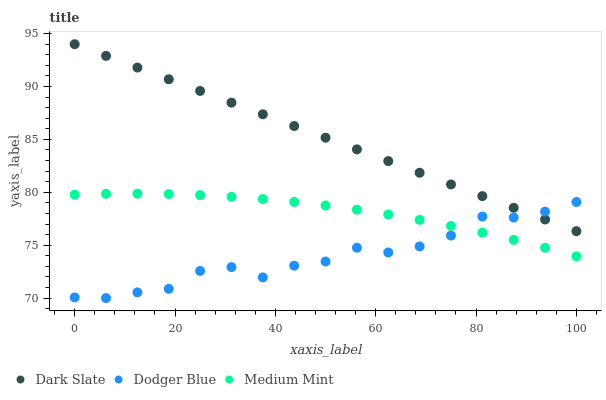Does Dodger Blue have the minimum area under the curve?
Answer yes or no. Yes. Does Dark Slate have the maximum area under the curve?
Answer yes or no. Yes. Does Dark Slate have the minimum area under the curve?
Answer yes or no. No. Does Dodger Blue have the maximum area under the curve?
Answer yes or no. No. Is Dark Slate the smoothest?
Answer yes or no. Yes. Is Dodger Blue the roughest?
Answer yes or no. Yes. Is Dodger Blue the smoothest?
Answer yes or no. No. Is Dark Slate the roughest?
Answer yes or no. No. Does Dodger Blue have the lowest value?
Answer yes or no. Yes. Does Dark Slate have the lowest value?
Answer yes or no. No. Does Dark Slate have the highest value?
Answer yes or no. Yes. Does Dodger Blue have the highest value?
Answer yes or no. No. Is Medium Mint less than Dark Slate?
Answer yes or no. Yes. Is Dark Slate greater than Medium Mint?
Answer yes or no. Yes. Does Dark Slate intersect Dodger Blue?
Answer yes or no. Yes. Is Dark Slate less than Dodger Blue?
Answer yes or no. No. Is Dark Slate greater than Dodger Blue?
Answer yes or no. No. Does Medium Mint intersect Dark Slate?
Answer yes or no. No. 